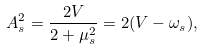<formula> <loc_0><loc_0><loc_500><loc_500>A _ { s } ^ { 2 } = \frac { 2 V } { 2 + \mu _ { s } ^ { 2 } } = 2 ( V - \omega _ { s } ) ,</formula> 